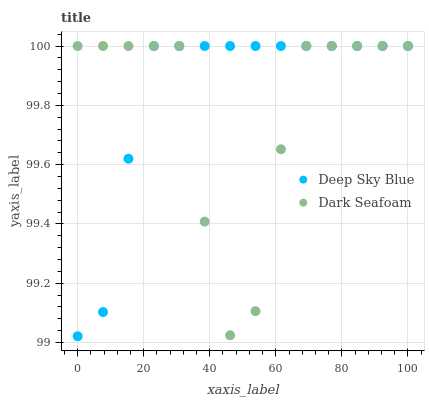Does Dark Seafoam have the minimum area under the curve?
Answer yes or no. Yes. Does Deep Sky Blue have the maximum area under the curve?
Answer yes or no. Yes. Does Deep Sky Blue have the minimum area under the curve?
Answer yes or no. No. Is Deep Sky Blue the smoothest?
Answer yes or no. Yes. Is Dark Seafoam the roughest?
Answer yes or no. Yes. Is Deep Sky Blue the roughest?
Answer yes or no. No. Does Deep Sky Blue have the lowest value?
Answer yes or no. Yes. Does Deep Sky Blue have the highest value?
Answer yes or no. Yes. Does Deep Sky Blue intersect Dark Seafoam?
Answer yes or no. Yes. Is Deep Sky Blue less than Dark Seafoam?
Answer yes or no. No. Is Deep Sky Blue greater than Dark Seafoam?
Answer yes or no. No. 